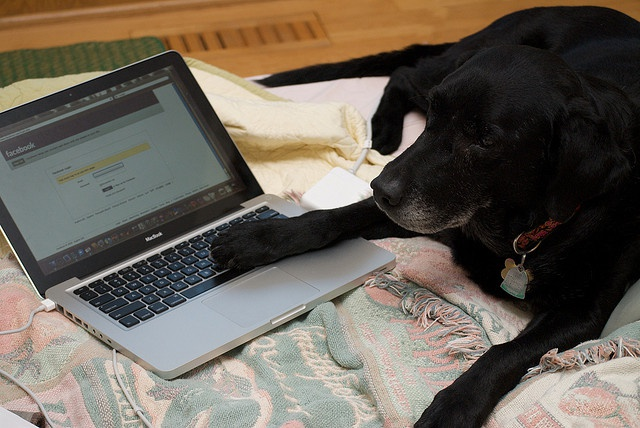Describe the objects in this image and their specific colors. I can see bed in maroon, darkgray, lightgray, and tan tones, dog in maroon, black, and gray tones, laptop in maroon, gray, black, and darkgray tones, and keyboard in maroon, black, gray, navy, and blue tones in this image. 